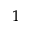Convert formula to latex. <formula><loc_0><loc_0><loc_500><loc_500>^ { 1 }</formula> 